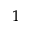Convert formula to latex. <formula><loc_0><loc_0><loc_500><loc_500>^ { 1 }</formula> 